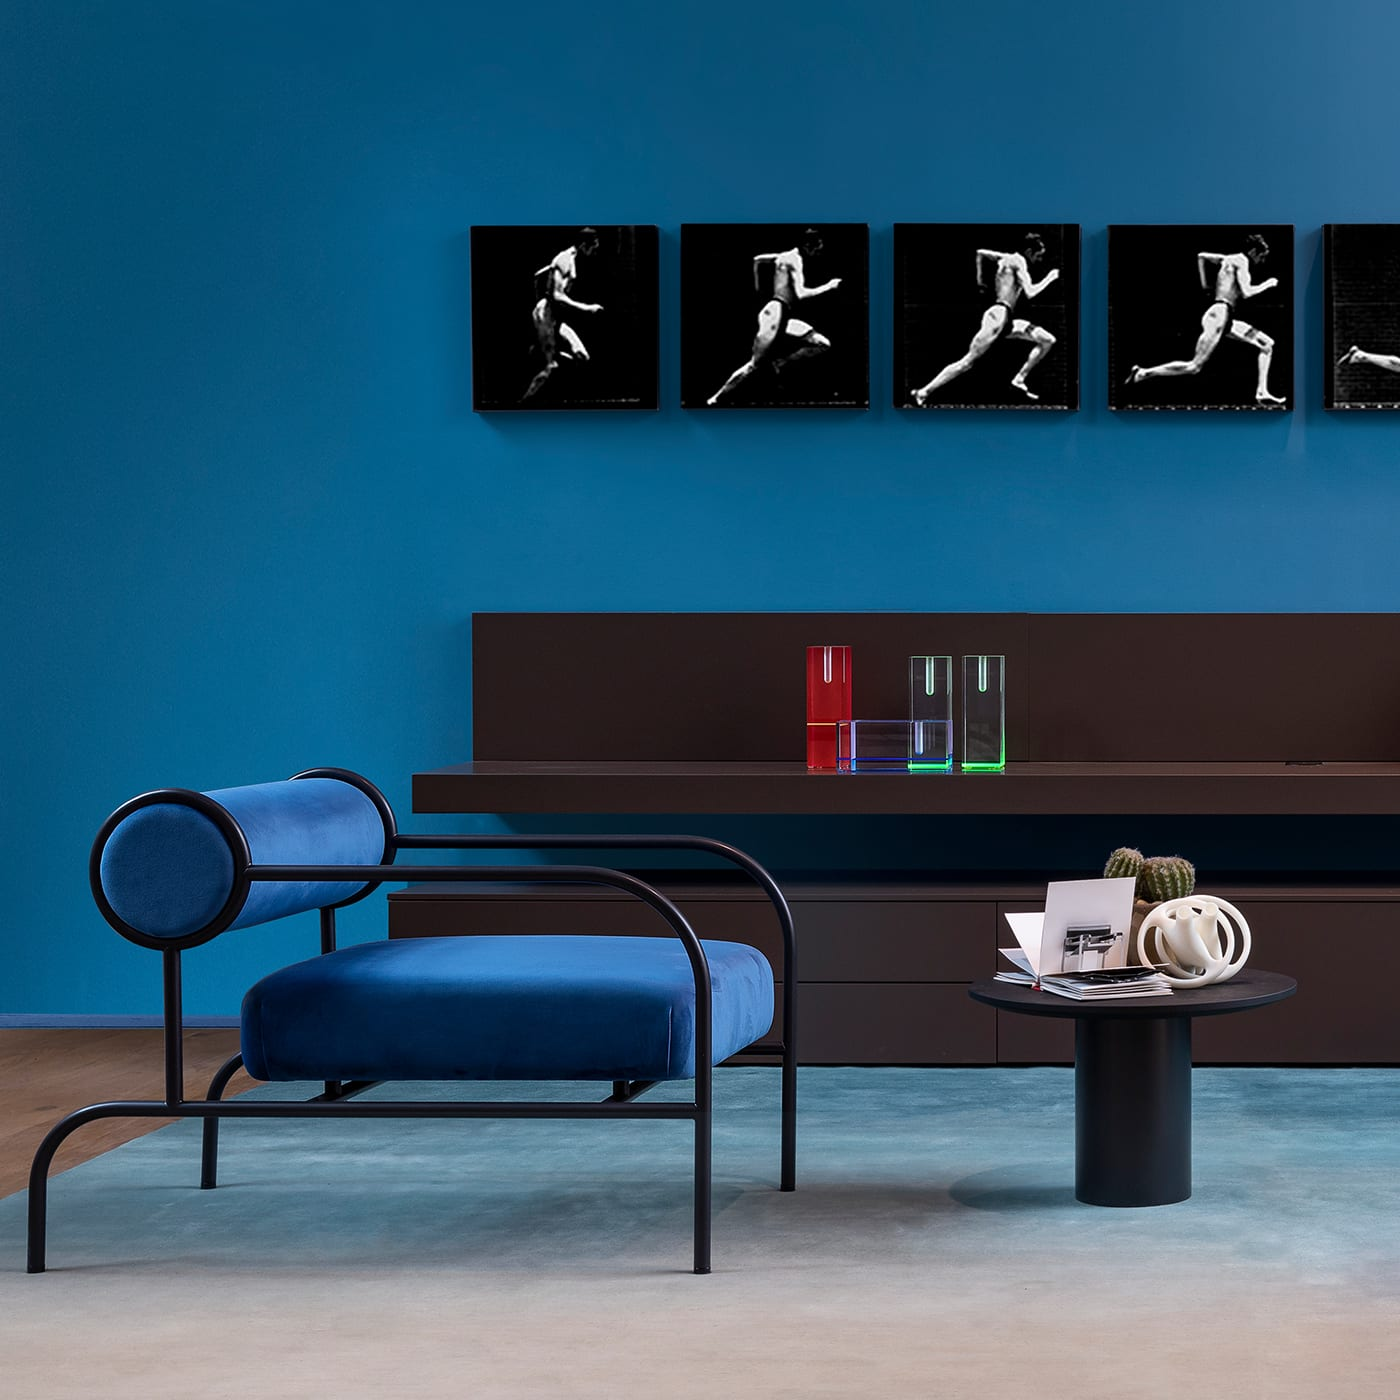What is the primary color theme of the room? The room primarily features a rich blue color theme, which is applied on the wall and the lounge chair, creating a sense of deep calm and sophistication. 